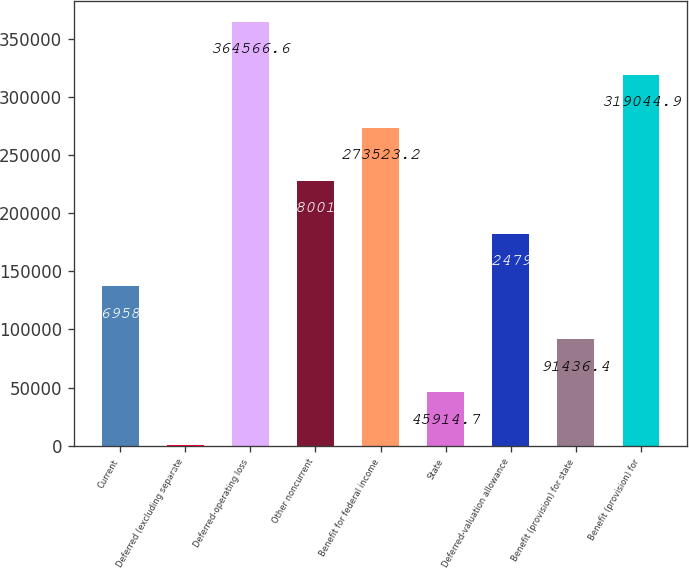Convert chart to OTSL. <chart><loc_0><loc_0><loc_500><loc_500><bar_chart><fcel>Current<fcel>Deferred (excluding separate<fcel>Deferred-operating loss<fcel>Other noncurrent<fcel>Benefit for federal income<fcel>State<fcel>Deferred-valuation allowance<fcel>Benefit (provision) for state<fcel>Benefit (provision) for<nl><fcel>136958<fcel>393<fcel>364567<fcel>228002<fcel>273523<fcel>45914.7<fcel>182480<fcel>91436.4<fcel>319045<nl></chart> 